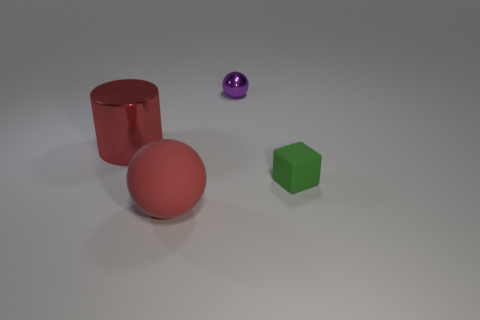The purple shiny thing that is the same size as the green object is what shape?
Your answer should be compact. Sphere. What number of other things are the same color as the matte ball?
Offer a very short reply. 1. How many big rubber cylinders are there?
Your response must be concise. 0. How many objects are on the left side of the small ball and behind the green matte object?
Offer a terse response. 1. What is the material of the small sphere?
Make the answer very short. Metal. Are there any small purple metal spheres?
Offer a very short reply. Yes. There is a sphere on the right side of the red rubber ball; what is its color?
Your response must be concise. Purple. There is a tiny thing on the left side of the tiny thing that is to the right of the metallic sphere; what number of purple metallic things are in front of it?
Give a very brief answer. 0. There is a thing that is behind the cube and in front of the purple sphere; what is its material?
Make the answer very short. Metal. Do the purple sphere and the small object in front of the tiny metal sphere have the same material?
Ensure brevity in your answer.  No. 